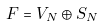<formula> <loc_0><loc_0><loc_500><loc_500>F = V _ { N } \oplus S _ { N }</formula> 